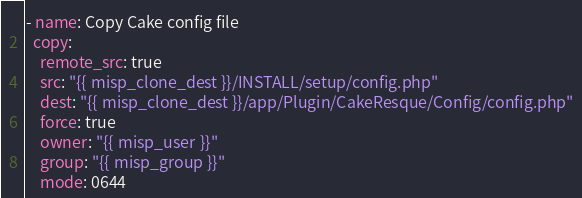Convert code to text. <code><loc_0><loc_0><loc_500><loc_500><_YAML_>- name: Copy Cake config file
  copy:
    remote_src: true
    src: "{{ misp_clone_dest }}/INSTALL/setup/config.php"
    dest: "{{ misp_clone_dest }}/app/Plugin/CakeResque/Config/config.php"
    force: true
    owner: "{{ misp_user }}"
    group: "{{ misp_group }}"
    mode: 0644
</code> 